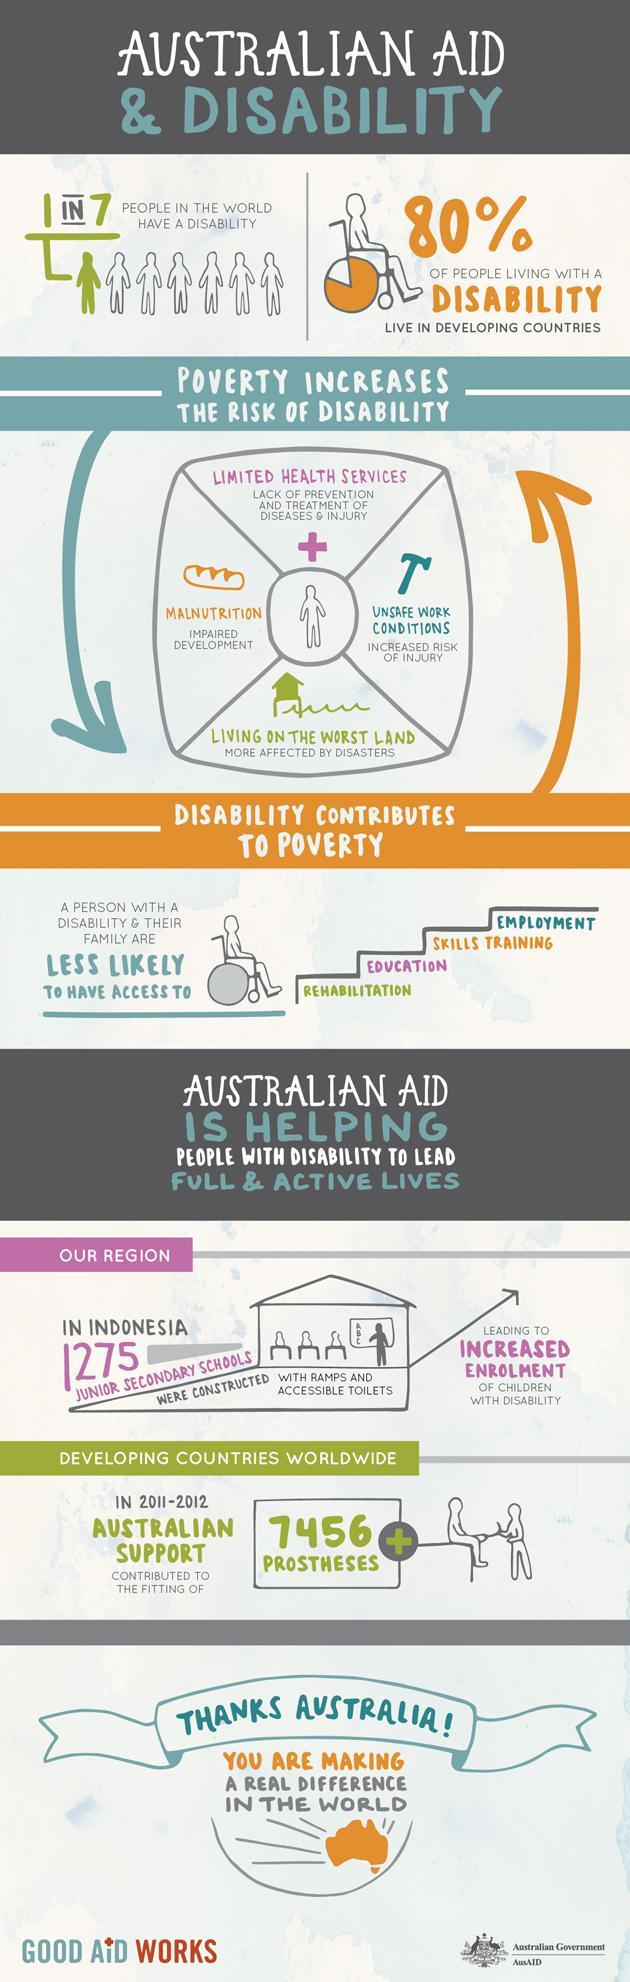How many schools were designed for disabled children in Indonesia?
Answer the question with a short phrase. 1275 